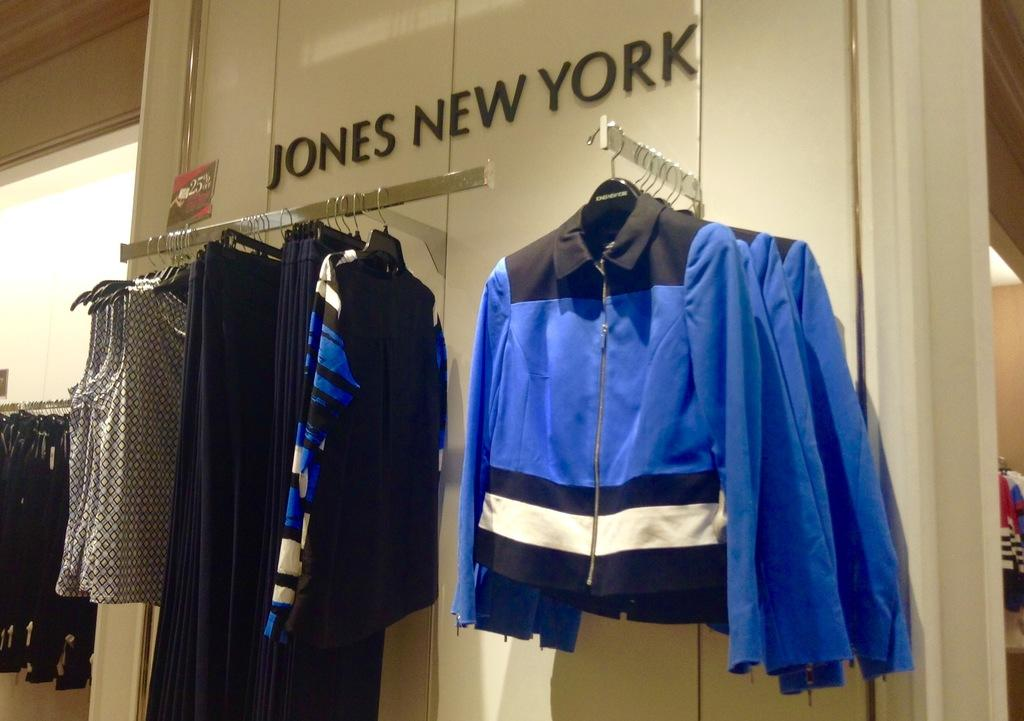<image>
Render a clear and concise summary of the photo. Jones New York clothing display including jackets and vests. 